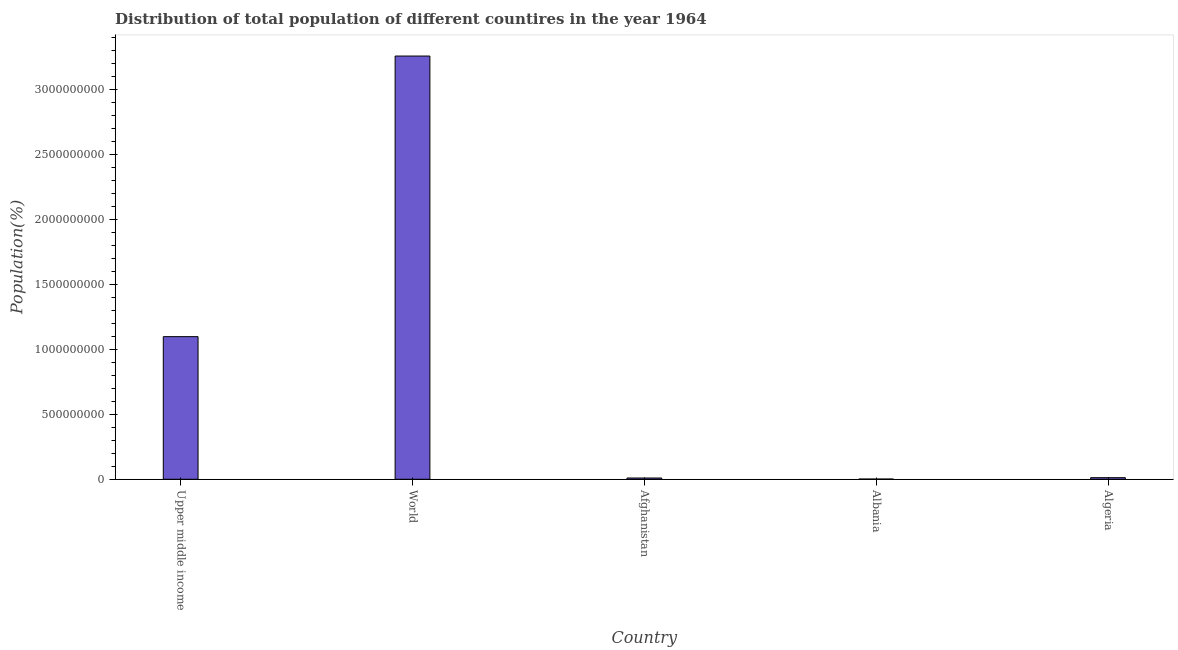Does the graph contain any zero values?
Give a very brief answer. No. Does the graph contain grids?
Keep it short and to the point. No. What is the title of the graph?
Your answer should be compact. Distribution of total population of different countires in the year 1964. What is the label or title of the Y-axis?
Provide a short and direct response. Population(%). What is the population in Algeria?
Ensure brevity in your answer.  1.23e+07. Across all countries, what is the maximum population?
Provide a succinct answer. 3.26e+09. Across all countries, what is the minimum population?
Ensure brevity in your answer.  1.81e+06. In which country was the population minimum?
Your answer should be compact. Albania. What is the sum of the population?
Keep it short and to the point. 4.38e+09. What is the difference between the population in Algeria and Upper middle income?
Offer a terse response. -1.09e+09. What is the average population per country?
Make the answer very short. 8.76e+08. What is the median population?
Your answer should be very brief. 1.23e+07. In how many countries, is the population greater than 2000000000 %?
Give a very brief answer. 1. What is the ratio of the population in Albania to that in World?
Offer a very short reply. 0. Is the population in Algeria less than that in Upper middle income?
Keep it short and to the point. Yes. What is the difference between the highest and the second highest population?
Keep it short and to the point. 2.16e+09. What is the difference between the highest and the lowest population?
Make the answer very short. 3.26e+09. In how many countries, is the population greater than the average population taken over all countries?
Keep it short and to the point. 2. What is the difference between two consecutive major ticks on the Y-axis?
Your answer should be very brief. 5.00e+08. Are the values on the major ticks of Y-axis written in scientific E-notation?
Your answer should be very brief. No. What is the Population(%) in Upper middle income?
Keep it short and to the point. 1.10e+09. What is the Population(%) in World?
Keep it short and to the point. 3.26e+09. What is the Population(%) of Afghanistan?
Make the answer very short. 9.73e+06. What is the Population(%) in Albania?
Give a very brief answer. 1.81e+06. What is the Population(%) in Algeria?
Make the answer very short. 1.23e+07. What is the difference between the Population(%) in Upper middle income and World?
Offer a very short reply. -2.16e+09. What is the difference between the Population(%) in Upper middle income and Afghanistan?
Your answer should be compact. 1.09e+09. What is the difference between the Population(%) in Upper middle income and Albania?
Offer a very short reply. 1.10e+09. What is the difference between the Population(%) in Upper middle income and Algeria?
Your response must be concise. 1.09e+09. What is the difference between the Population(%) in World and Afghanistan?
Provide a short and direct response. 3.25e+09. What is the difference between the Population(%) in World and Albania?
Provide a short and direct response. 3.26e+09. What is the difference between the Population(%) in World and Algeria?
Provide a succinct answer. 3.25e+09. What is the difference between the Population(%) in Afghanistan and Albania?
Keep it short and to the point. 7.91e+06. What is the difference between the Population(%) in Afghanistan and Algeria?
Keep it short and to the point. -2.57e+06. What is the difference between the Population(%) in Albania and Algeria?
Offer a terse response. -1.05e+07. What is the ratio of the Population(%) in Upper middle income to that in World?
Provide a short and direct response. 0.34. What is the ratio of the Population(%) in Upper middle income to that in Afghanistan?
Your response must be concise. 112.9. What is the ratio of the Population(%) in Upper middle income to that in Albania?
Offer a very short reply. 605.43. What is the ratio of the Population(%) in Upper middle income to that in Algeria?
Provide a succinct answer. 89.33. What is the ratio of the Population(%) in World to that in Afghanistan?
Your answer should be compact. 335.02. What is the ratio of the Population(%) in World to that in Albania?
Offer a very short reply. 1796.62. What is the ratio of the Population(%) in World to that in Algeria?
Your answer should be very brief. 265.07. What is the ratio of the Population(%) in Afghanistan to that in Albania?
Offer a terse response. 5.36. What is the ratio of the Population(%) in Afghanistan to that in Algeria?
Keep it short and to the point. 0.79. What is the ratio of the Population(%) in Albania to that in Algeria?
Give a very brief answer. 0.15. 